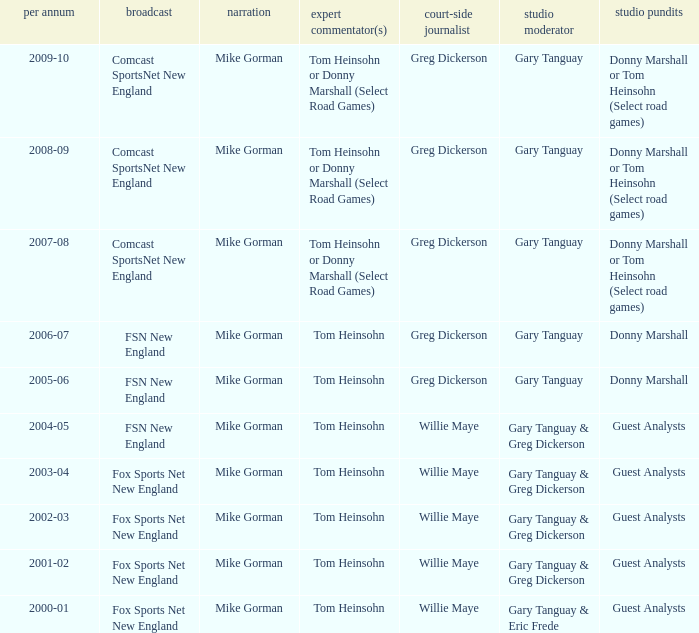Which Color commentator has a Channel of fsn new england, and a Year of 2004-05? Tom Heinsohn. 